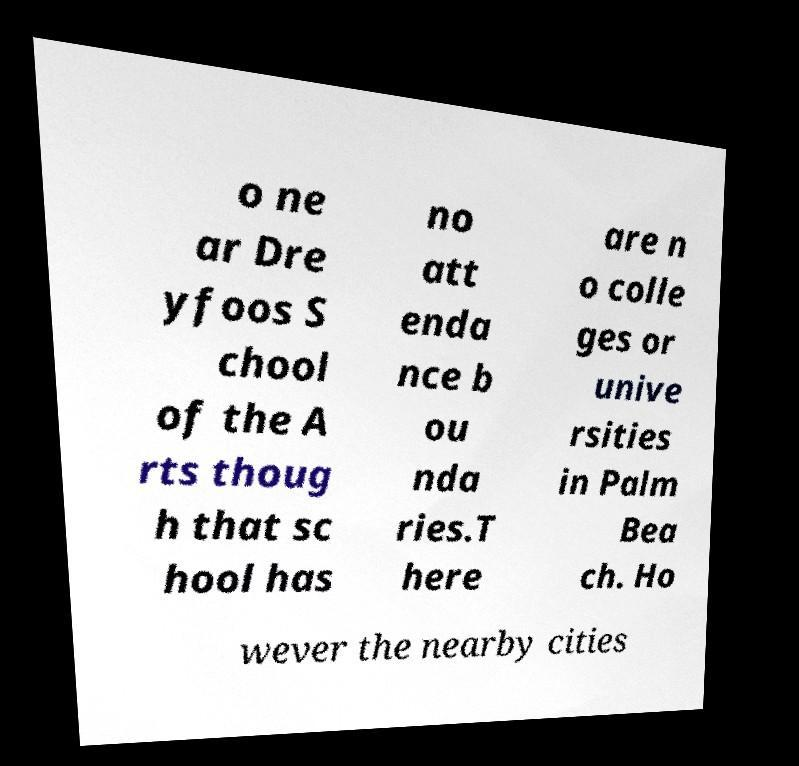There's text embedded in this image that I need extracted. Can you transcribe it verbatim? o ne ar Dre yfoos S chool of the A rts thoug h that sc hool has no att enda nce b ou nda ries.T here are n o colle ges or unive rsities in Palm Bea ch. Ho wever the nearby cities 